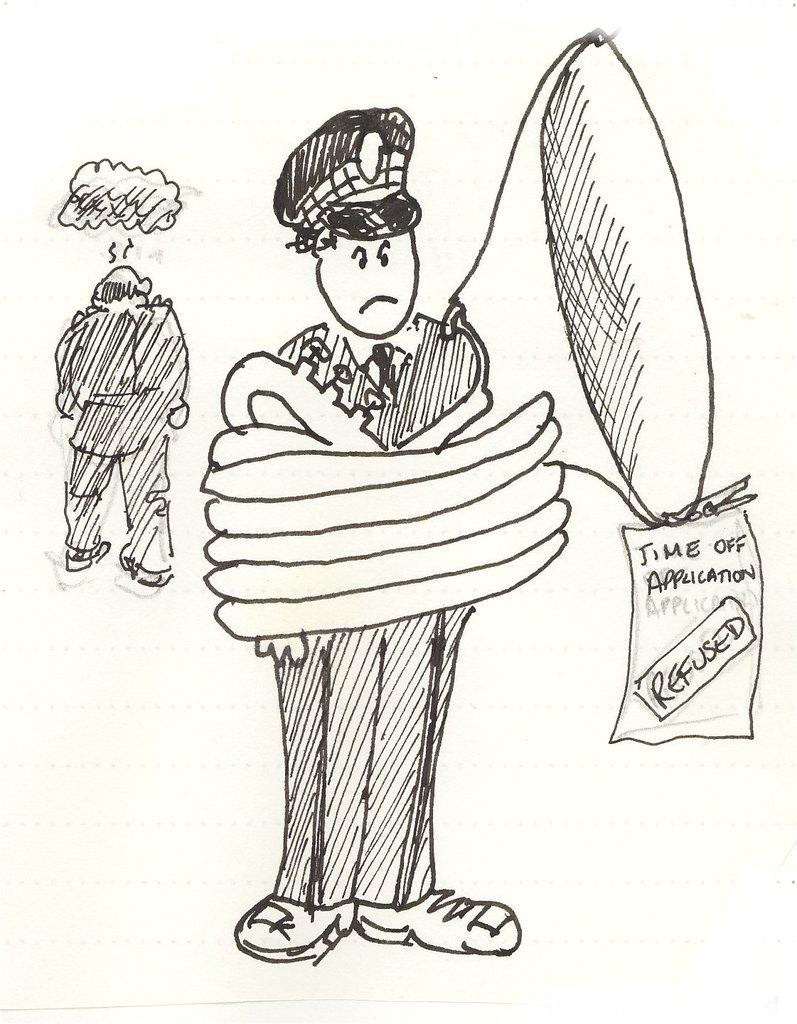What is depicted in the image? There are drawings of a person in the image. Are there any words or letters in the image? Yes, there is text in the image. How many family members are present in the image? There is no reference to a family or any family members in the image; it only contains drawings of a person and text. 